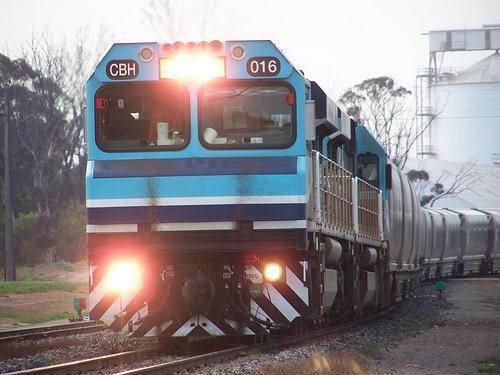How many trains are there?
Give a very brief answer. 1. 